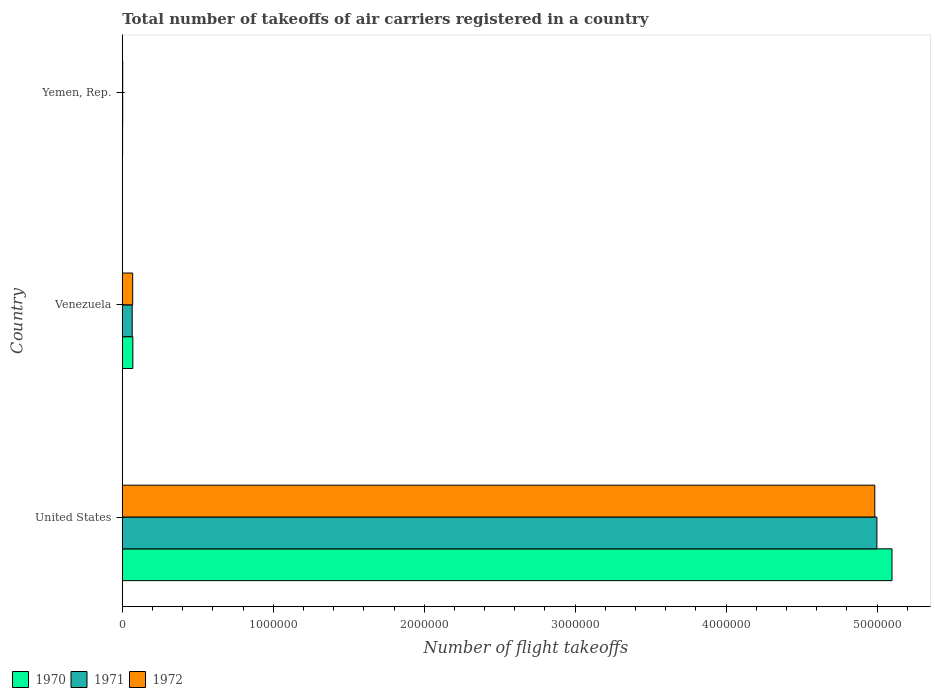Are the number of bars per tick equal to the number of legend labels?
Your answer should be compact. Yes. Are the number of bars on each tick of the Y-axis equal?
Your answer should be compact. Yes. How many bars are there on the 2nd tick from the bottom?
Keep it short and to the point. 3. What is the label of the 3rd group of bars from the top?
Give a very brief answer. United States. In how many cases, is the number of bars for a given country not equal to the number of legend labels?
Your response must be concise. 0. What is the total number of flight takeoffs in 1971 in United States?
Give a very brief answer. 5.00e+06. Across all countries, what is the maximum total number of flight takeoffs in 1972?
Your answer should be compact. 4.99e+06. Across all countries, what is the minimum total number of flight takeoffs in 1972?
Keep it short and to the point. 2900. In which country was the total number of flight takeoffs in 1972 minimum?
Give a very brief answer. Yemen, Rep. What is the total total number of flight takeoffs in 1970 in the graph?
Your answer should be very brief. 5.17e+06. What is the difference between the total number of flight takeoffs in 1970 in United States and that in Venezuela?
Provide a short and direct response. 5.03e+06. What is the difference between the total number of flight takeoffs in 1971 in Venezuela and the total number of flight takeoffs in 1970 in United States?
Give a very brief answer. -5.03e+06. What is the average total number of flight takeoffs in 1971 per country?
Offer a terse response. 1.69e+06. What is the difference between the total number of flight takeoffs in 1971 and total number of flight takeoffs in 1970 in United States?
Your answer should be very brief. -1.00e+05. In how many countries, is the total number of flight takeoffs in 1971 greater than 4400000 ?
Offer a very short reply. 1. What is the ratio of the total number of flight takeoffs in 1970 in Venezuela to that in Yemen, Rep.?
Your answer should be very brief. 31.86. What is the difference between the highest and the second highest total number of flight takeoffs in 1972?
Offer a terse response. 4.92e+06. What is the difference between the highest and the lowest total number of flight takeoffs in 1972?
Offer a terse response. 4.98e+06. Is it the case that in every country, the sum of the total number of flight takeoffs in 1972 and total number of flight takeoffs in 1970 is greater than the total number of flight takeoffs in 1971?
Offer a terse response. Yes. How many bars are there?
Give a very brief answer. 9. What is the difference between two consecutive major ticks on the X-axis?
Provide a short and direct response. 1.00e+06. Are the values on the major ticks of X-axis written in scientific E-notation?
Keep it short and to the point. No. Does the graph contain any zero values?
Your answer should be compact. No. Does the graph contain grids?
Your answer should be compact. No. How many legend labels are there?
Your answer should be very brief. 3. What is the title of the graph?
Give a very brief answer. Total number of takeoffs of air carriers registered in a country. Does "1964" appear as one of the legend labels in the graph?
Keep it short and to the point. No. What is the label or title of the X-axis?
Keep it short and to the point. Number of flight takeoffs. What is the Number of flight takeoffs of 1970 in United States?
Provide a succinct answer. 5.10e+06. What is the Number of flight takeoffs in 1971 in United States?
Provide a short and direct response. 5.00e+06. What is the Number of flight takeoffs of 1972 in United States?
Keep it short and to the point. 4.99e+06. What is the Number of flight takeoffs in 1970 in Venezuela?
Your response must be concise. 7.01e+04. What is the Number of flight takeoffs in 1971 in Venezuela?
Your answer should be very brief. 6.56e+04. What is the Number of flight takeoffs in 1972 in Venezuela?
Offer a terse response. 6.89e+04. What is the Number of flight takeoffs of 1970 in Yemen, Rep.?
Offer a terse response. 2200. What is the Number of flight takeoffs in 1971 in Yemen, Rep.?
Your answer should be very brief. 2800. What is the Number of flight takeoffs in 1972 in Yemen, Rep.?
Offer a terse response. 2900. Across all countries, what is the maximum Number of flight takeoffs in 1970?
Keep it short and to the point. 5.10e+06. Across all countries, what is the maximum Number of flight takeoffs of 1971?
Make the answer very short. 5.00e+06. Across all countries, what is the maximum Number of flight takeoffs of 1972?
Provide a short and direct response. 4.99e+06. Across all countries, what is the minimum Number of flight takeoffs of 1970?
Make the answer very short. 2200. Across all countries, what is the minimum Number of flight takeoffs in 1971?
Provide a short and direct response. 2800. Across all countries, what is the minimum Number of flight takeoffs of 1972?
Keep it short and to the point. 2900. What is the total Number of flight takeoffs of 1970 in the graph?
Keep it short and to the point. 5.17e+06. What is the total Number of flight takeoffs of 1971 in the graph?
Provide a short and direct response. 5.07e+06. What is the total Number of flight takeoffs of 1972 in the graph?
Make the answer very short. 5.06e+06. What is the difference between the Number of flight takeoffs in 1970 in United States and that in Venezuela?
Provide a succinct answer. 5.03e+06. What is the difference between the Number of flight takeoffs in 1971 in United States and that in Venezuela?
Your answer should be very brief. 4.93e+06. What is the difference between the Number of flight takeoffs in 1972 in United States and that in Venezuela?
Offer a terse response. 4.92e+06. What is the difference between the Number of flight takeoffs of 1970 in United States and that in Yemen, Rep.?
Your response must be concise. 5.10e+06. What is the difference between the Number of flight takeoffs in 1971 in United States and that in Yemen, Rep.?
Provide a succinct answer. 5.00e+06. What is the difference between the Number of flight takeoffs of 1972 in United States and that in Yemen, Rep.?
Your answer should be compact. 4.98e+06. What is the difference between the Number of flight takeoffs in 1970 in Venezuela and that in Yemen, Rep.?
Your response must be concise. 6.79e+04. What is the difference between the Number of flight takeoffs in 1971 in Venezuela and that in Yemen, Rep.?
Offer a very short reply. 6.28e+04. What is the difference between the Number of flight takeoffs of 1972 in Venezuela and that in Yemen, Rep.?
Your response must be concise. 6.60e+04. What is the difference between the Number of flight takeoffs of 1970 in United States and the Number of flight takeoffs of 1971 in Venezuela?
Give a very brief answer. 5.03e+06. What is the difference between the Number of flight takeoffs in 1970 in United States and the Number of flight takeoffs in 1972 in Venezuela?
Give a very brief answer. 5.03e+06. What is the difference between the Number of flight takeoffs in 1971 in United States and the Number of flight takeoffs in 1972 in Venezuela?
Your answer should be compact. 4.93e+06. What is the difference between the Number of flight takeoffs in 1970 in United States and the Number of flight takeoffs in 1971 in Yemen, Rep.?
Make the answer very short. 5.10e+06. What is the difference between the Number of flight takeoffs of 1970 in United States and the Number of flight takeoffs of 1972 in Yemen, Rep.?
Provide a short and direct response. 5.10e+06. What is the difference between the Number of flight takeoffs of 1971 in United States and the Number of flight takeoffs of 1972 in Yemen, Rep.?
Your answer should be very brief. 5.00e+06. What is the difference between the Number of flight takeoffs in 1970 in Venezuela and the Number of flight takeoffs in 1971 in Yemen, Rep.?
Keep it short and to the point. 6.73e+04. What is the difference between the Number of flight takeoffs of 1970 in Venezuela and the Number of flight takeoffs of 1972 in Yemen, Rep.?
Your response must be concise. 6.72e+04. What is the difference between the Number of flight takeoffs in 1971 in Venezuela and the Number of flight takeoffs in 1972 in Yemen, Rep.?
Offer a very short reply. 6.27e+04. What is the average Number of flight takeoffs in 1970 per country?
Offer a very short reply. 1.72e+06. What is the average Number of flight takeoffs of 1971 per country?
Your answer should be compact. 1.69e+06. What is the average Number of flight takeoffs of 1972 per country?
Offer a terse response. 1.69e+06. What is the difference between the Number of flight takeoffs of 1970 and Number of flight takeoffs of 1971 in United States?
Give a very brief answer. 1.00e+05. What is the difference between the Number of flight takeoffs in 1970 and Number of flight takeoffs in 1972 in United States?
Offer a terse response. 1.14e+05. What is the difference between the Number of flight takeoffs of 1971 and Number of flight takeoffs of 1972 in United States?
Provide a succinct answer. 1.40e+04. What is the difference between the Number of flight takeoffs of 1970 and Number of flight takeoffs of 1971 in Venezuela?
Make the answer very short. 4500. What is the difference between the Number of flight takeoffs in 1970 and Number of flight takeoffs in 1972 in Venezuela?
Your response must be concise. 1200. What is the difference between the Number of flight takeoffs in 1971 and Number of flight takeoffs in 1972 in Venezuela?
Give a very brief answer. -3300. What is the difference between the Number of flight takeoffs of 1970 and Number of flight takeoffs of 1971 in Yemen, Rep.?
Your answer should be very brief. -600. What is the difference between the Number of flight takeoffs in 1970 and Number of flight takeoffs in 1972 in Yemen, Rep.?
Your response must be concise. -700. What is the difference between the Number of flight takeoffs in 1971 and Number of flight takeoffs in 1972 in Yemen, Rep.?
Keep it short and to the point. -100. What is the ratio of the Number of flight takeoffs of 1970 in United States to that in Venezuela?
Offer a terse response. 72.74. What is the ratio of the Number of flight takeoffs of 1971 in United States to that in Venezuela?
Provide a short and direct response. 76.21. What is the ratio of the Number of flight takeoffs of 1972 in United States to that in Venezuela?
Your answer should be compact. 72.35. What is the ratio of the Number of flight takeoffs in 1970 in United States to that in Yemen, Rep.?
Provide a succinct answer. 2317.82. What is the ratio of the Number of flight takeoffs of 1971 in United States to that in Yemen, Rep.?
Keep it short and to the point. 1785.43. What is the ratio of the Number of flight takeoffs of 1972 in United States to that in Yemen, Rep.?
Your answer should be very brief. 1719.03. What is the ratio of the Number of flight takeoffs of 1970 in Venezuela to that in Yemen, Rep.?
Ensure brevity in your answer.  31.86. What is the ratio of the Number of flight takeoffs of 1971 in Venezuela to that in Yemen, Rep.?
Provide a succinct answer. 23.43. What is the ratio of the Number of flight takeoffs in 1972 in Venezuela to that in Yemen, Rep.?
Ensure brevity in your answer.  23.76. What is the difference between the highest and the second highest Number of flight takeoffs in 1970?
Keep it short and to the point. 5.03e+06. What is the difference between the highest and the second highest Number of flight takeoffs in 1971?
Give a very brief answer. 4.93e+06. What is the difference between the highest and the second highest Number of flight takeoffs in 1972?
Give a very brief answer. 4.92e+06. What is the difference between the highest and the lowest Number of flight takeoffs in 1970?
Provide a succinct answer. 5.10e+06. What is the difference between the highest and the lowest Number of flight takeoffs of 1971?
Offer a terse response. 5.00e+06. What is the difference between the highest and the lowest Number of flight takeoffs in 1972?
Ensure brevity in your answer.  4.98e+06. 